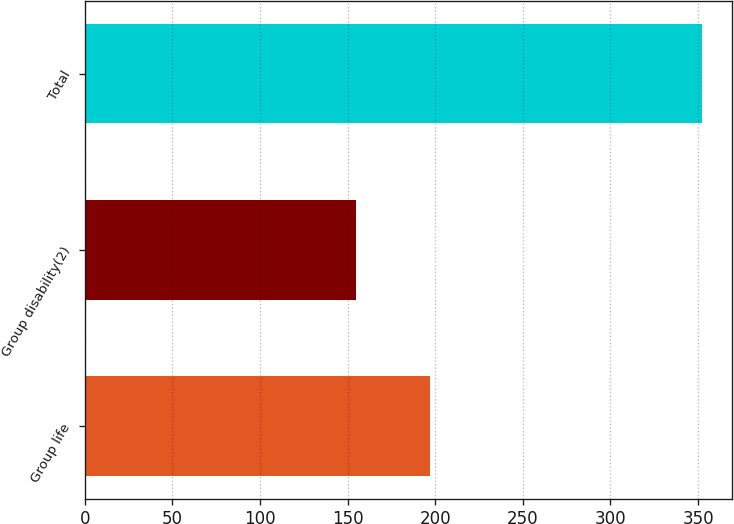Convert chart to OTSL. <chart><loc_0><loc_0><loc_500><loc_500><bar_chart><fcel>Group life<fcel>Group disability(2)<fcel>Total<nl><fcel>197<fcel>155<fcel>352<nl></chart> 